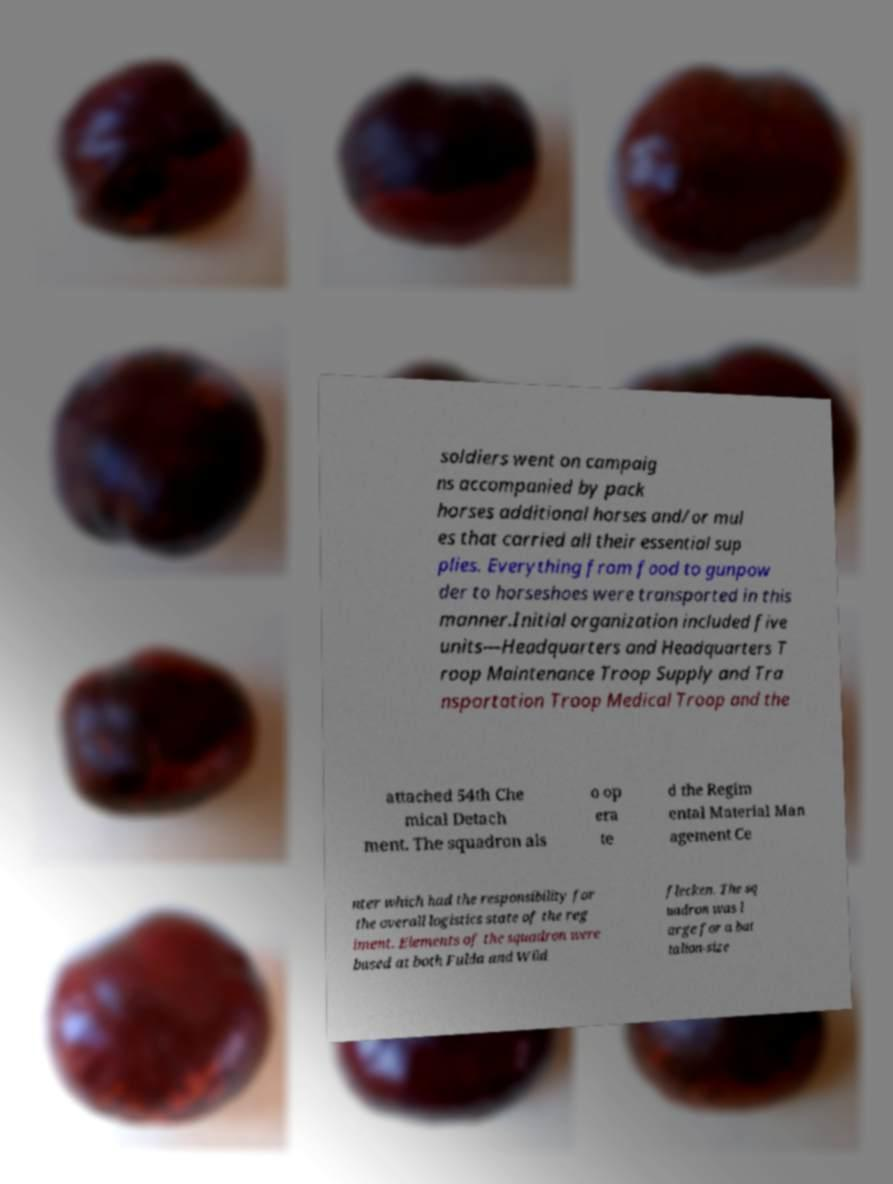Can you accurately transcribe the text from the provided image for me? soldiers went on campaig ns accompanied by pack horses additional horses and/or mul es that carried all their essential sup plies. Everything from food to gunpow der to horseshoes were transported in this manner.Initial organization included five units—Headquarters and Headquarters T roop Maintenance Troop Supply and Tra nsportation Troop Medical Troop and the attached 54th Che mical Detach ment. The squadron als o op era te d the Regim ental Material Man agement Ce nter which had the responsibility for the overall logistics state of the reg iment. Elements of the squadron were based at both Fulda and Wild flecken. The sq uadron was l arge for a bat talion-size 